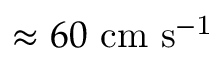Convert formula to latex. <formula><loc_0><loc_0><loc_500><loc_500>\approx 6 0 \ c m \ s ^ { - 1 }</formula> 